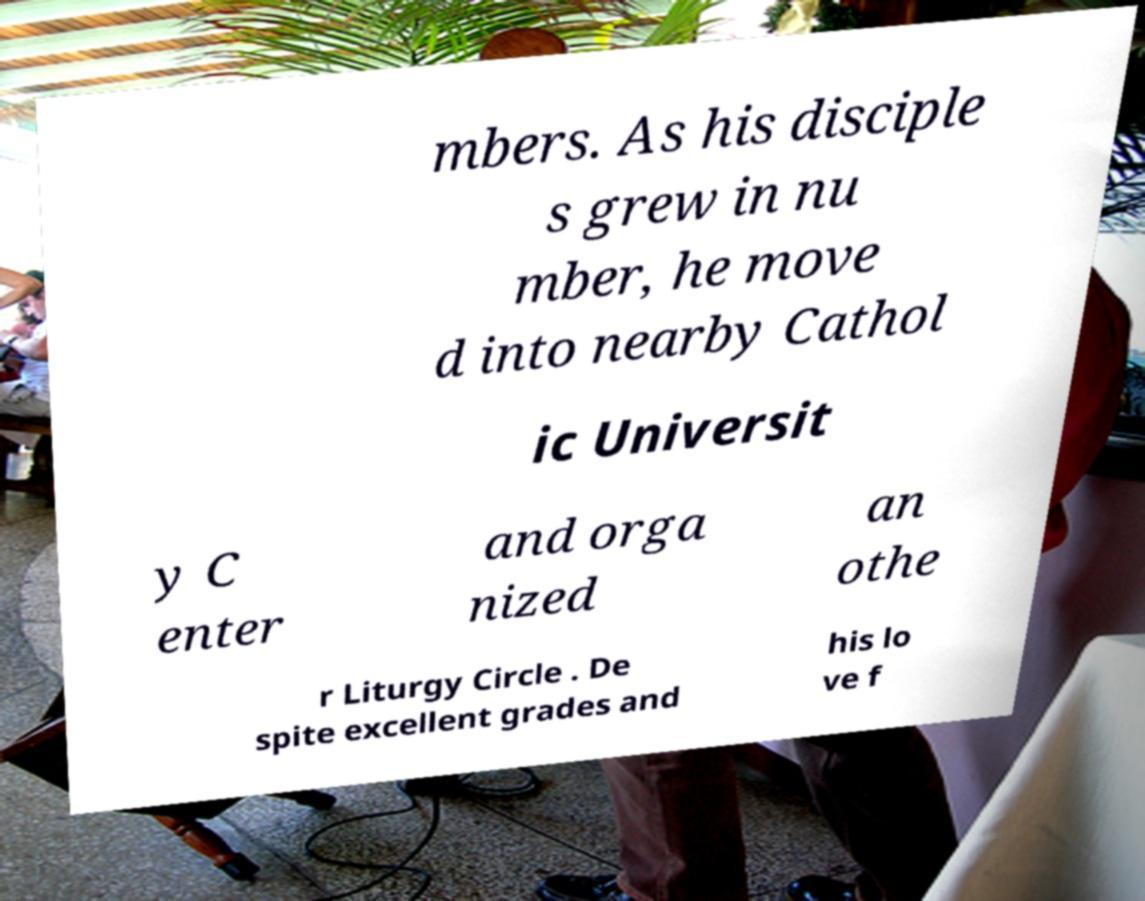Can you read and provide the text displayed in the image?This photo seems to have some interesting text. Can you extract and type it out for me? mbers. As his disciple s grew in nu mber, he move d into nearby Cathol ic Universit y C enter and orga nized an othe r Liturgy Circle . De spite excellent grades and his lo ve f 